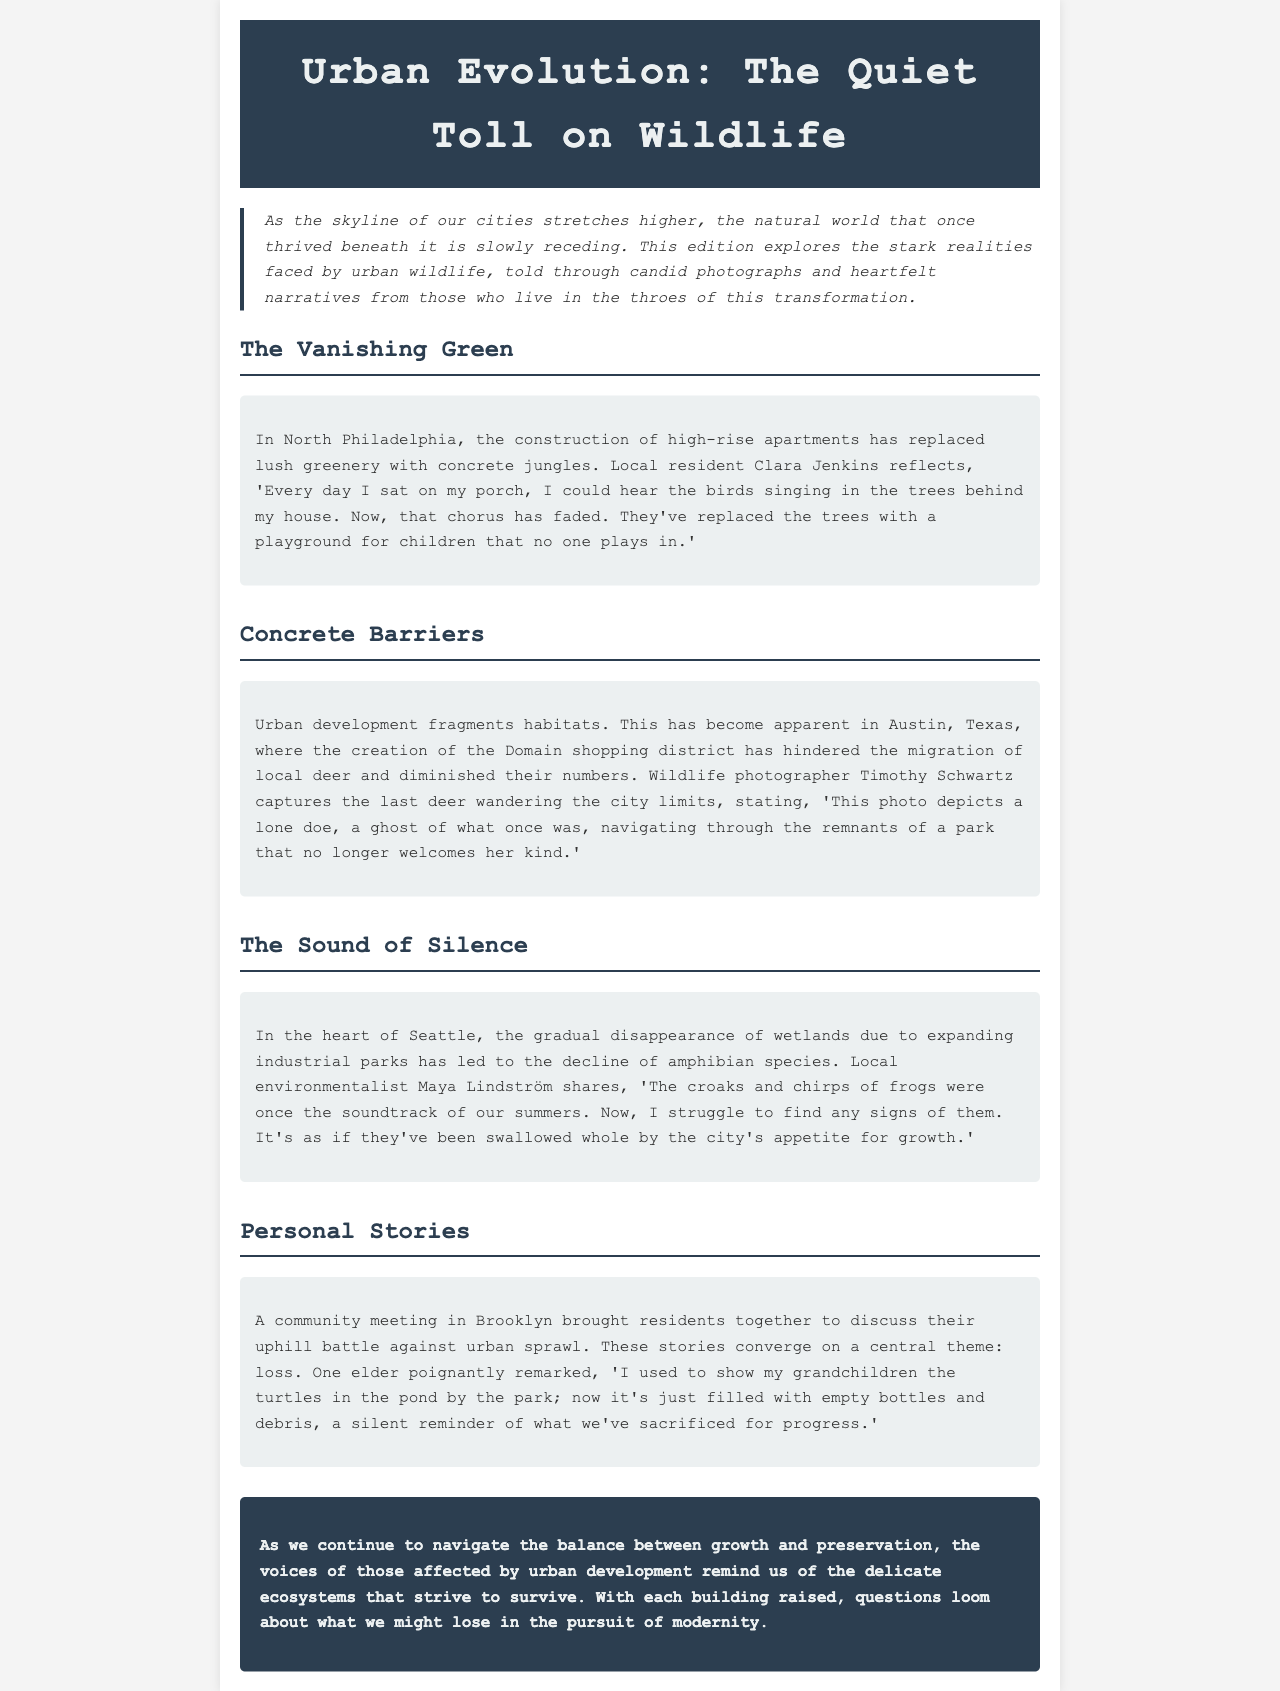What is the title of the newsletter? The title of the newsletter is prominently displayed at the top of the document.
Answer: Urban Evolution: The Quiet Toll on Wildlife Who is the local resident mentioned in North Philadelphia? Clara Jenkins is identified as the local resident in North Philadelphia who reflects on the loss of wildlife.
Answer: Clara Jenkins What urban development is mentioned in Austin, Texas? The creation of the Domain shopping district is discussed in relation to local wildlife.
Answer: The Domain shopping district What has caused a decline in amphibian species in Seattle? The disappearance of wetlands due to expanding industrial parks is stated as the reason for the decline.
Answer: Expanding industrial parks What was found in the pond by the park now, according to the elder? The elder describes the pond as now filled with empty bottles and debris, contrasting its former state.
Answer: Empty bottles and debris What is the central theme of the personal stories shared at the community meeting? The shared stories converge on a central theme regarding the impact of urban sprawl on wildlife.
Answer: Loss How are the voices of those affected by urban development described? They are described as reminders of the delicate ecosystems that strive to survive amidst urban expansion.
Answer: Reminders of delicate ecosystems What type of photography is mentioned in the document? Wildlife photography is referenced when discussing the impact of urbanization on animal migration.
Answer: Wildlife photography 